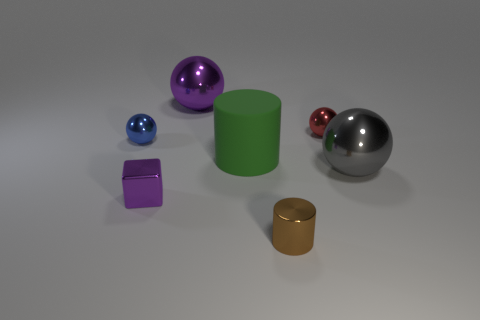Add 2 tiny purple shiny blocks. How many objects exist? 9 Subtract all gray metallic spheres. How many spheres are left? 3 Subtract all blue balls. How many balls are left? 3 Subtract all balls. How many objects are left? 3 Subtract all balls. Subtract all large matte cylinders. How many objects are left? 2 Add 2 big purple metallic balls. How many big purple metallic balls are left? 3 Add 2 purple metal objects. How many purple metal objects exist? 4 Subtract 0 yellow balls. How many objects are left? 7 Subtract 1 blocks. How many blocks are left? 0 Subtract all red spheres. Subtract all purple cylinders. How many spheres are left? 3 